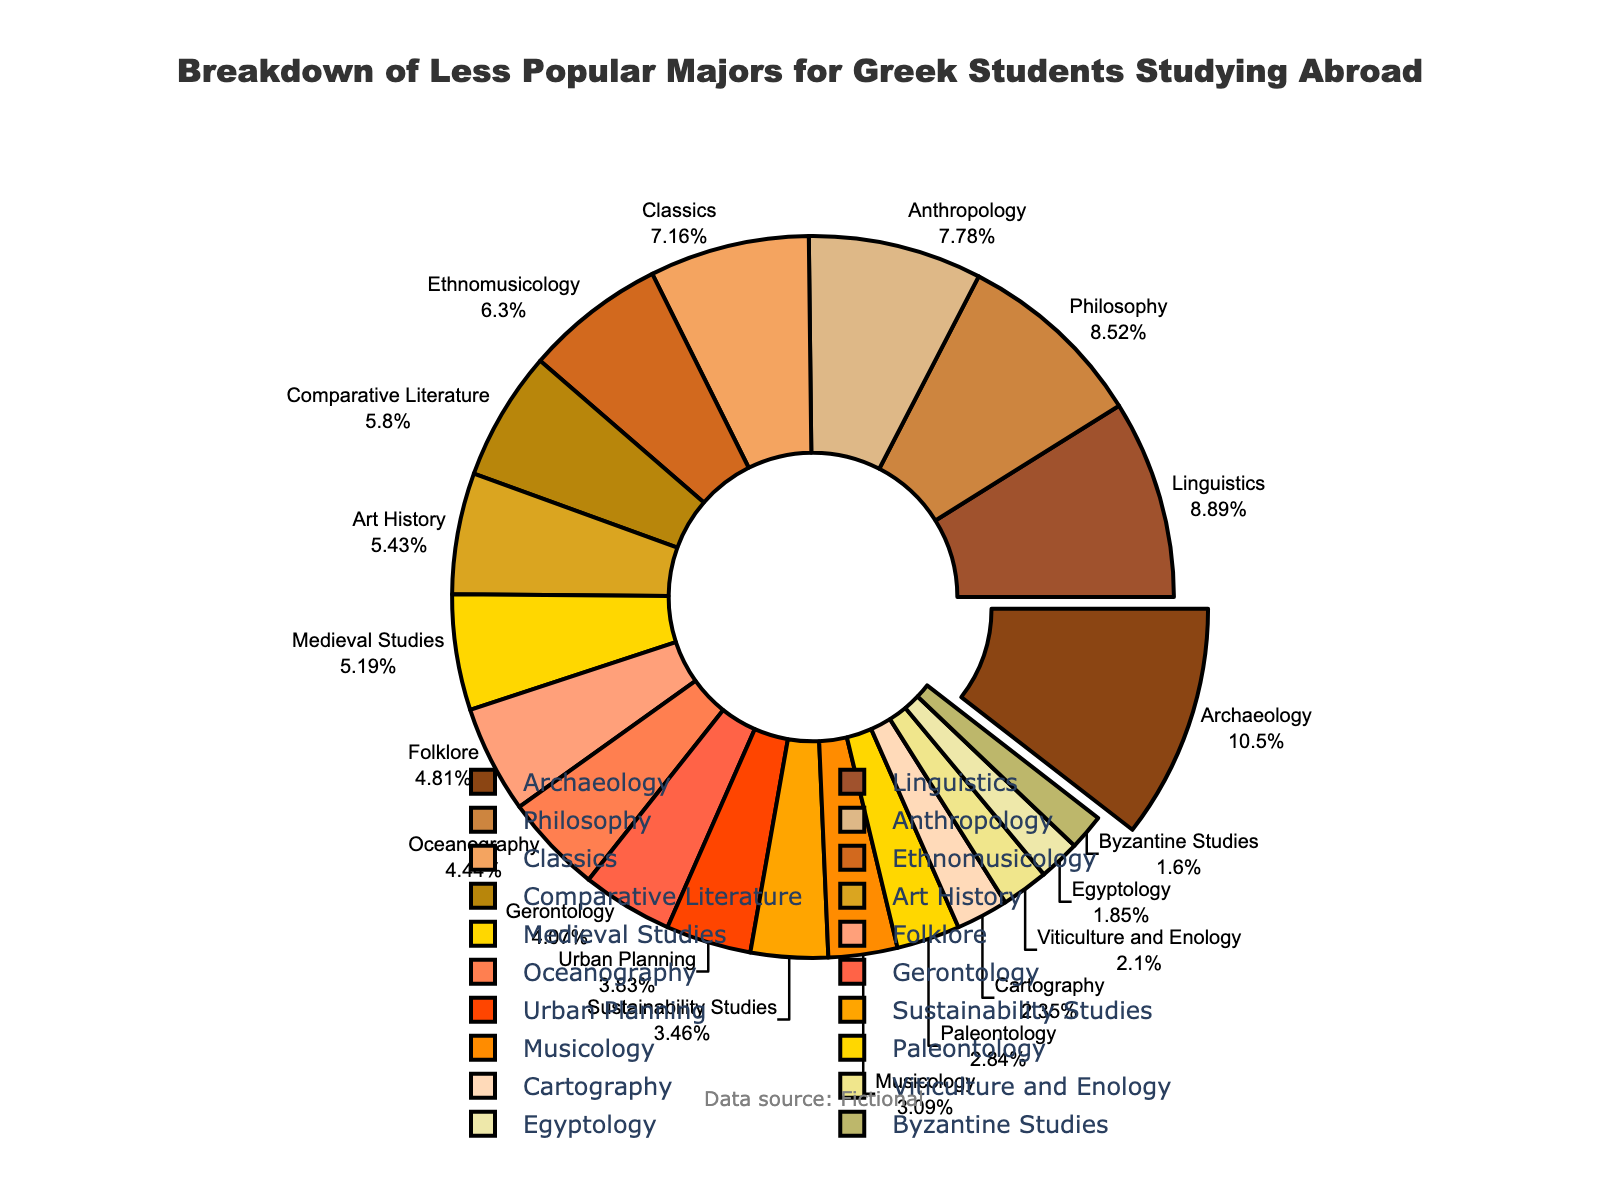What's the most popular less popular major chosen by Greek students studying abroad? The pie chart highlights the percentage of Greek students in less popular majors. The major with the largest slice is Archaeology, marked by the slice pulled out slightly from the center.
Answer: Archaeology Which major is chosen less frequently: Folklore or Gerontology? By comparing the sizes of the slices labeled "Folklore" and "Gerontology," Folklore is chosen less frequently as it occupies a smaller slice of the pie.
Answer: Folklore Sum of percentages for Linguistics, Philosophy, and Anthropology? First, find the percentages for each of these majors: Linguistics (7.2%), Philosophy (6.9%), and Anthropology (6.3%). Then sum the values: 7.2 + 6.9 + 6.3 = 20.4%.
Answer: 20.4% What is the difference in percentage between the least and the most popular majors? The most popular major is Archaeology at 8.5%, and the least popular major is Byzantine Studies at 1.3%. Subtract the smaller percentage from the larger: 8.5% - 1.3% = 7.2%.
Answer: 7.2% Which major is represented by the golden-yellow colored slice? The golden-yellow slice correlates to the label "Classics" in the legend, so Classics is represented by the golden-yellow color.
Answer: Classics Is the percentage of students studying Urban Planning higher or lower than those studying Sustainability Studies? Comparing the slices, Urban Planning has a percentage of 3.1%, while Sustainability Studies has a percentage of 2.8%. Therefore, Urban Planning is higher.
Answer: Higher What are the total percentages for majors related to history (Archaeology, Classics, and Medieval Studies)? Sum the percentages: Archaeology (8.5%), Classics (5.8%), and Medieval Studies (4.2%). So, 8.5 + 5.8 + 4.2 = 18.5%.
Answer: 18.5% Which two majors combined have an equal or almost equal percentage to Anthropology? Anthropology has a percentage of 6.3%. Combining Folklore (3.9%) and Urban Planning (3.1%) gives approximately 7.0%, which is close.
Answer: Folklore and Urban Planning What percentage of Greek students are studying majors related to geography (Cartography and Oceanography)? Sum the percentages for Cartography (1.9%) and Oceanography (3.6%). So, 1.9 + 3.6 = 5.5%.
Answer: 5.5% Which major has the smallest percentage? The smallest percentage is given to Byzantine Studies, marked at 1.3% on the chart.
Answer: Byzantine Studies 